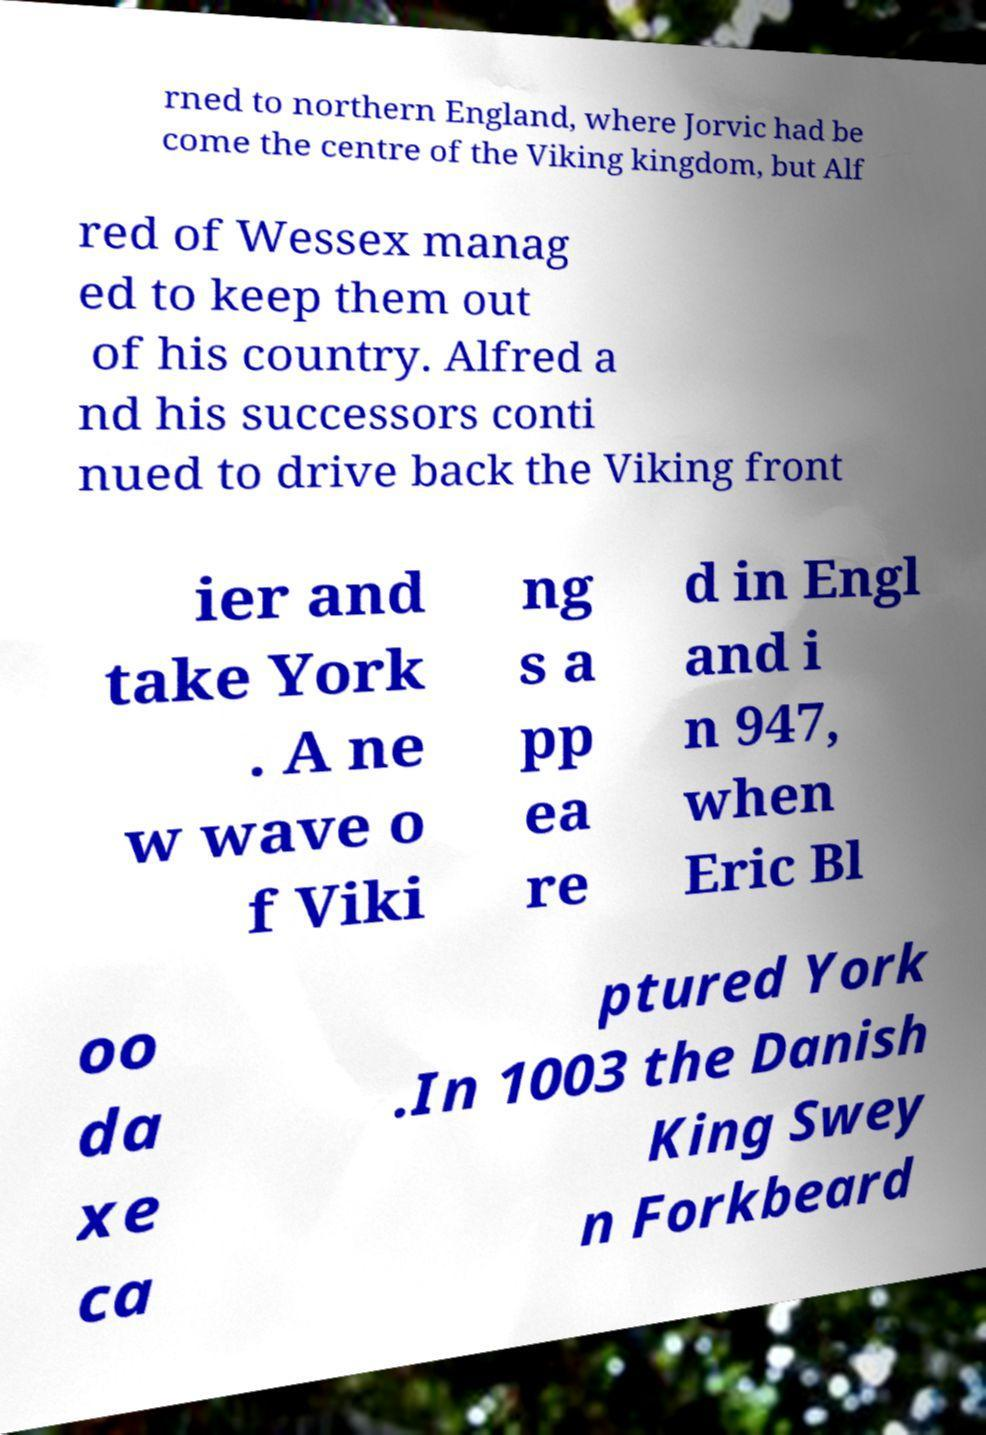Can you accurately transcribe the text from the provided image for me? rned to northern England, where Jorvic had be come the centre of the Viking kingdom, but Alf red of Wessex manag ed to keep them out of his country. Alfred a nd his successors conti nued to drive back the Viking front ier and take York . A ne w wave o f Viki ng s a pp ea re d in Engl and i n 947, when Eric Bl oo da xe ca ptured York .In 1003 the Danish King Swey n Forkbeard 